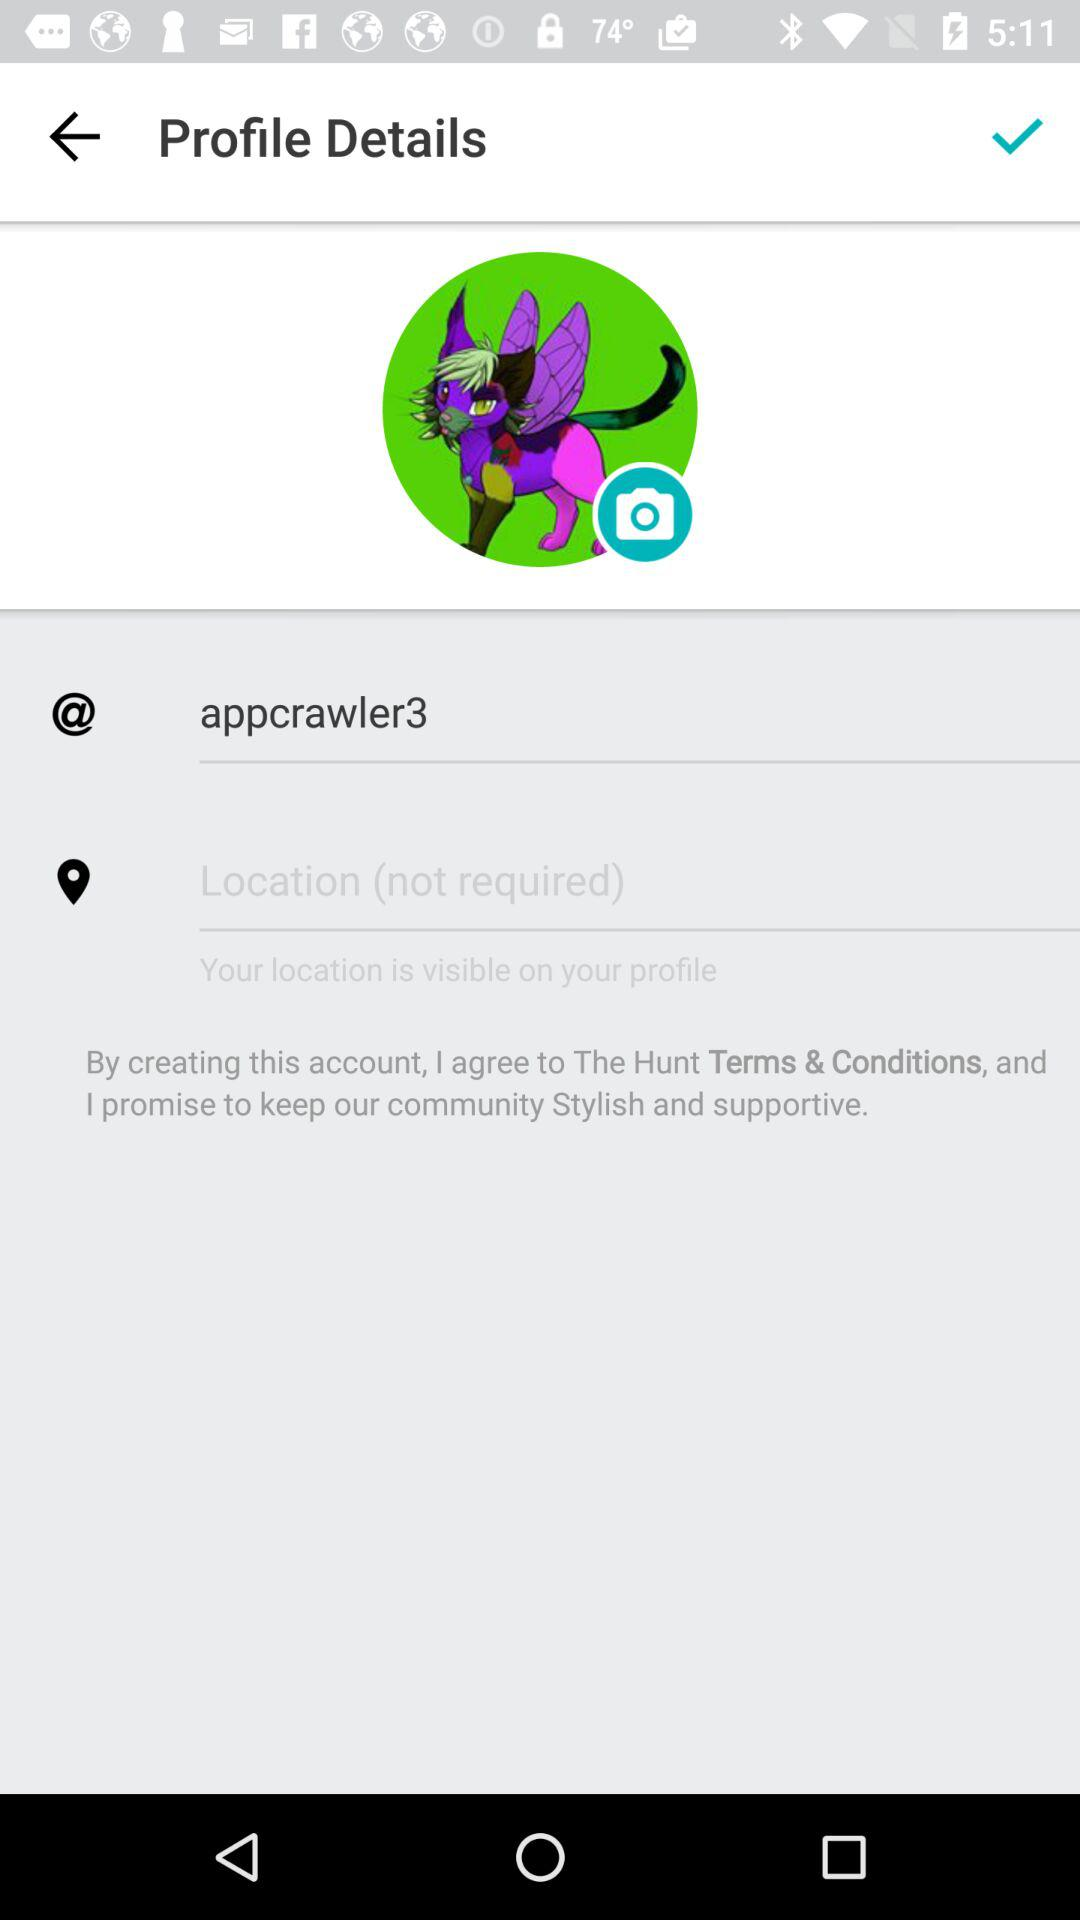What's the username? The username is "appcrawler3". 